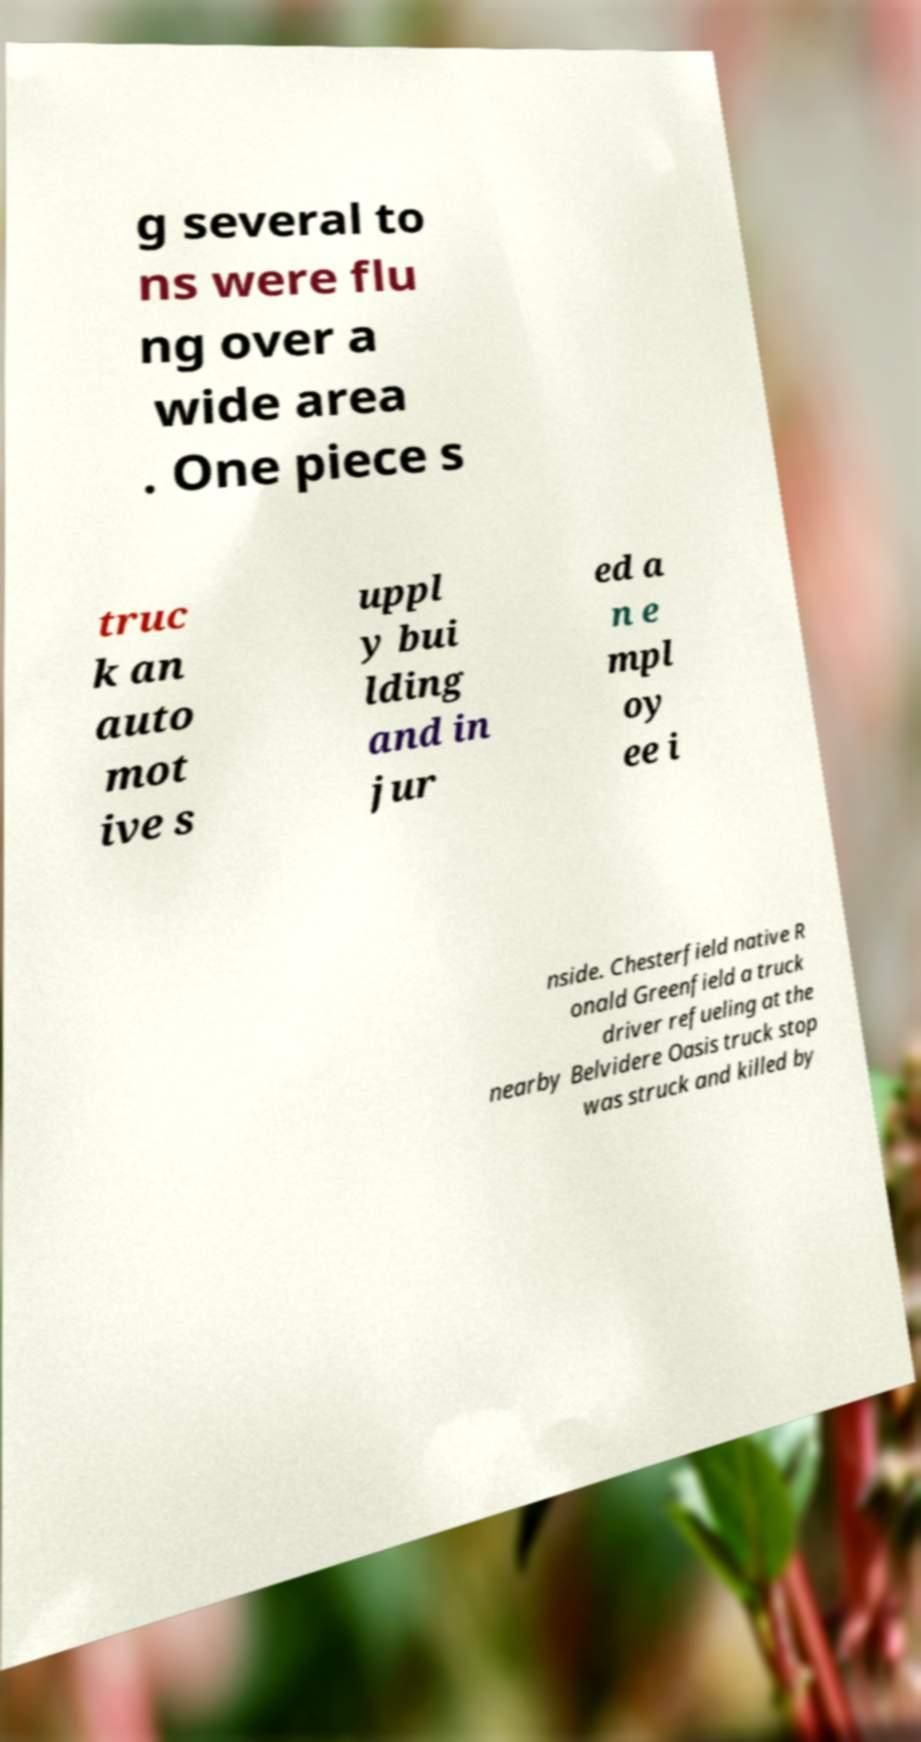I need the written content from this picture converted into text. Can you do that? g several to ns were flu ng over a wide area . One piece s truc k an auto mot ive s uppl y bui lding and in jur ed a n e mpl oy ee i nside. Chesterfield native R onald Greenfield a truck driver refueling at the nearby Belvidere Oasis truck stop was struck and killed by 